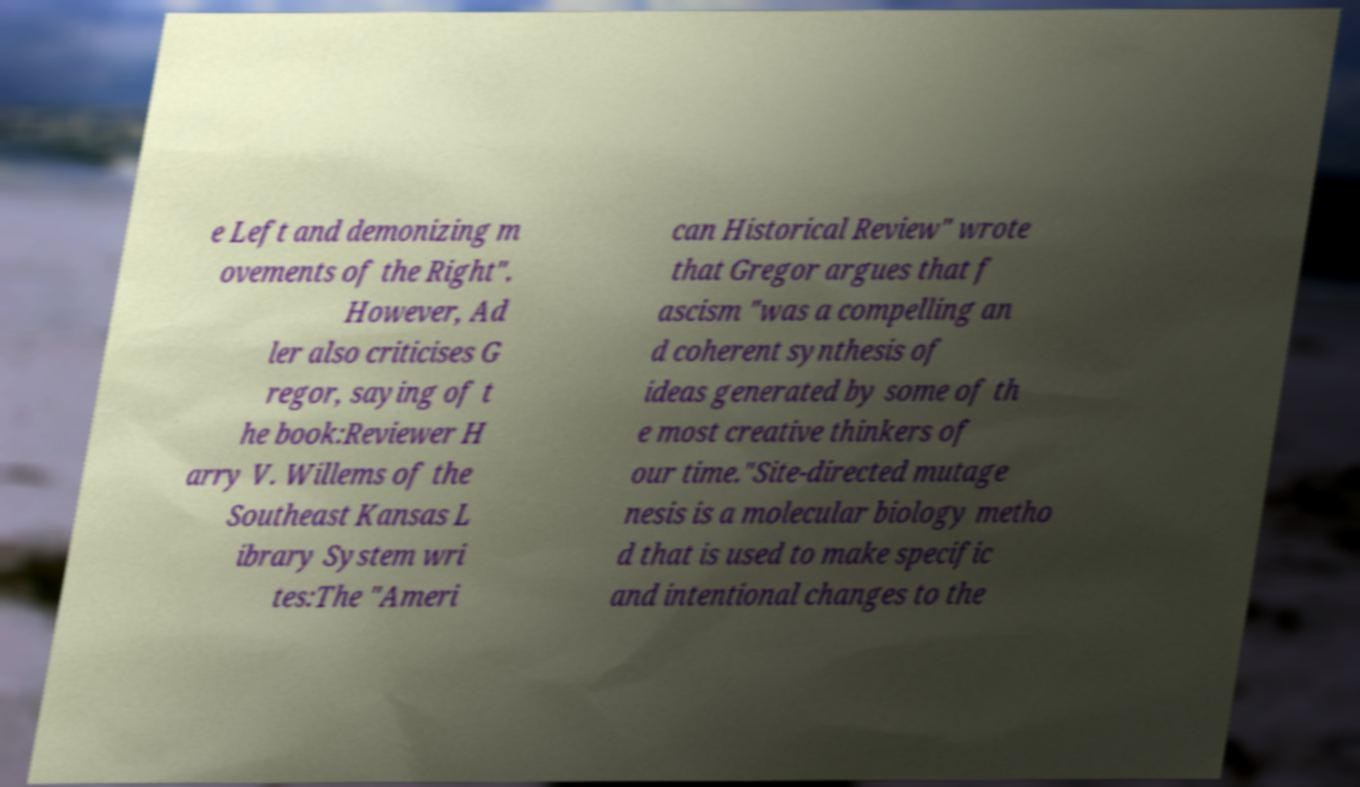Please read and relay the text visible in this image. What does it say? e Left and demonizing m ovements of the Right". However, Ad ler also criticises G regor, saying of t he book:Reviewer H arry V. Willems of the Southeast Kansas L ibrary System wri tes:The "Ameri can Historical Review" wrote that Gregor argues that f ascism "was a compelling an d coherent synthesis of ideas generated by some of th e most creative thinkers of our time."Site-directed mutage nesis is a molecular biology metho d that is used to make specific and intentional changes to the 